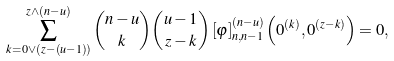<formula> <loc_0><loc_0><loc_500><loc_500>\sum _ { k = 0 \vee \left ( z - \left ( u - 1 \right ) \right ) } ^ { z \wedge \left ( n - u \right ) } \binom { n - u } { k } \binom { u - 1 } { z - k } \left [ \varphi \right ] _ { n , n - 1 } ^ { \left ( n - u \right ) } \left ( 0 ^ { \left ( k \right ) } , 0 ^ { \left ( z - k \right ) } \right ) = 0 ,</formula> 